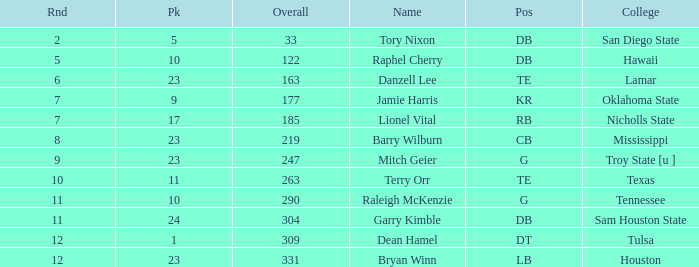Which Round is the highest one that has a Pick smaller than 10, and a Name of tory nixon? 2.0. 